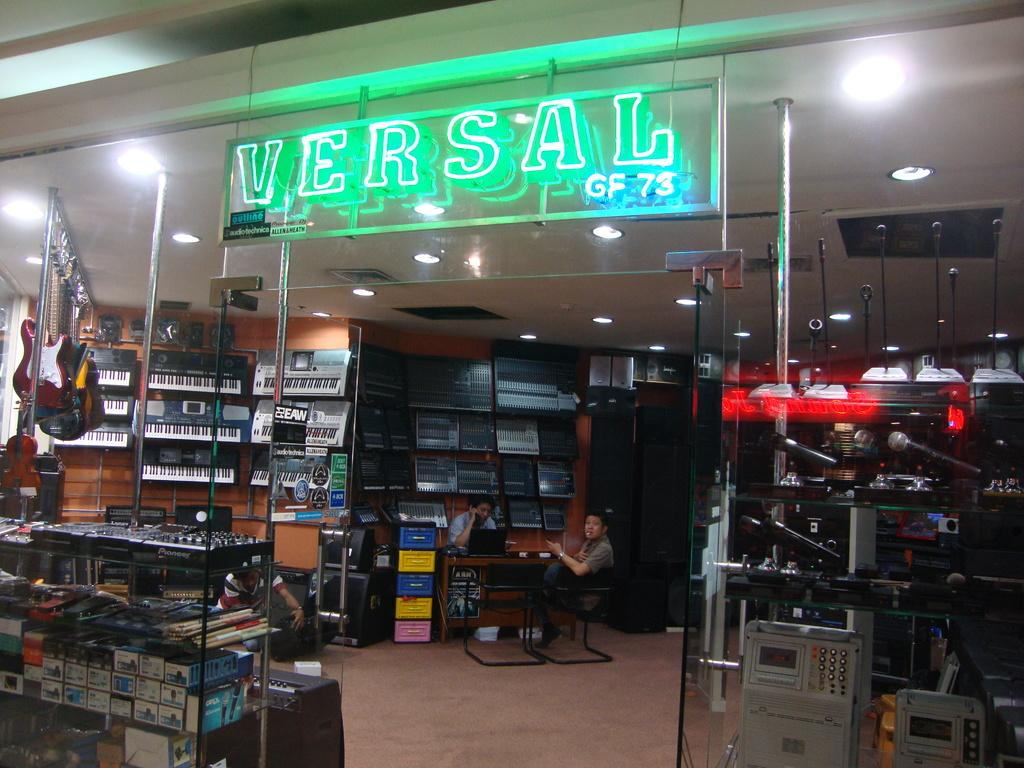<image>
Give a short and clear explanation of the subsequent image. Versal music store with a glass front for viewing and various musical equipment including what may be Fender Strata-casters hanging in their glory. 